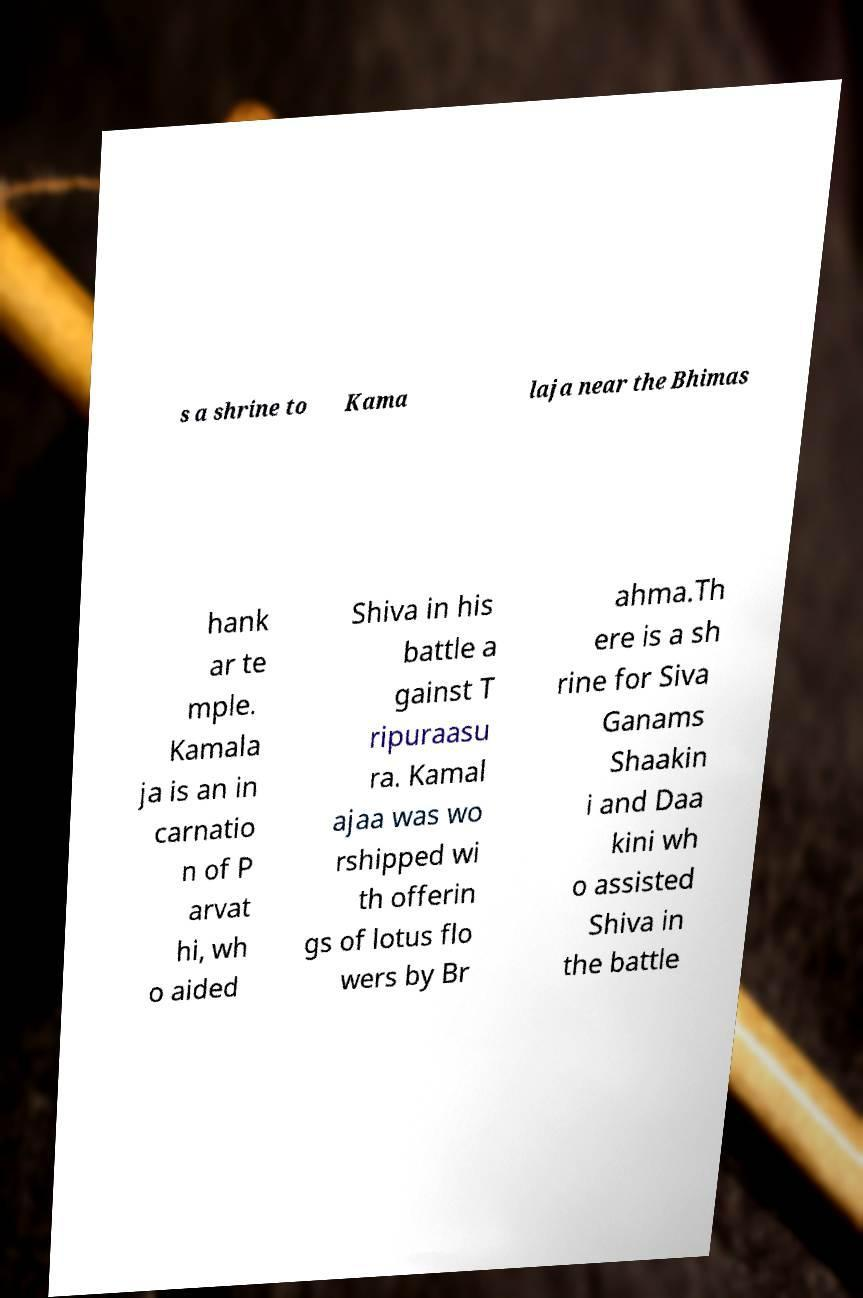For documentation purposes, I need the text within this image transcribed. Could you provide that? s a shrine to Kama laja near the Bhimas hank ar te mple. Kamala ja is an in carnatio n of P arvat hi, wh o aided Shiva in his battle a gainst T ripuraasu ra. Kamal ajaa was wo rshipped wi th offerin gs of lotus flo wers by Br ahma.Th ere is a sh rine for Siva Ganams Shaakin i and Daa kini wh o assisted Shiva in the battle 